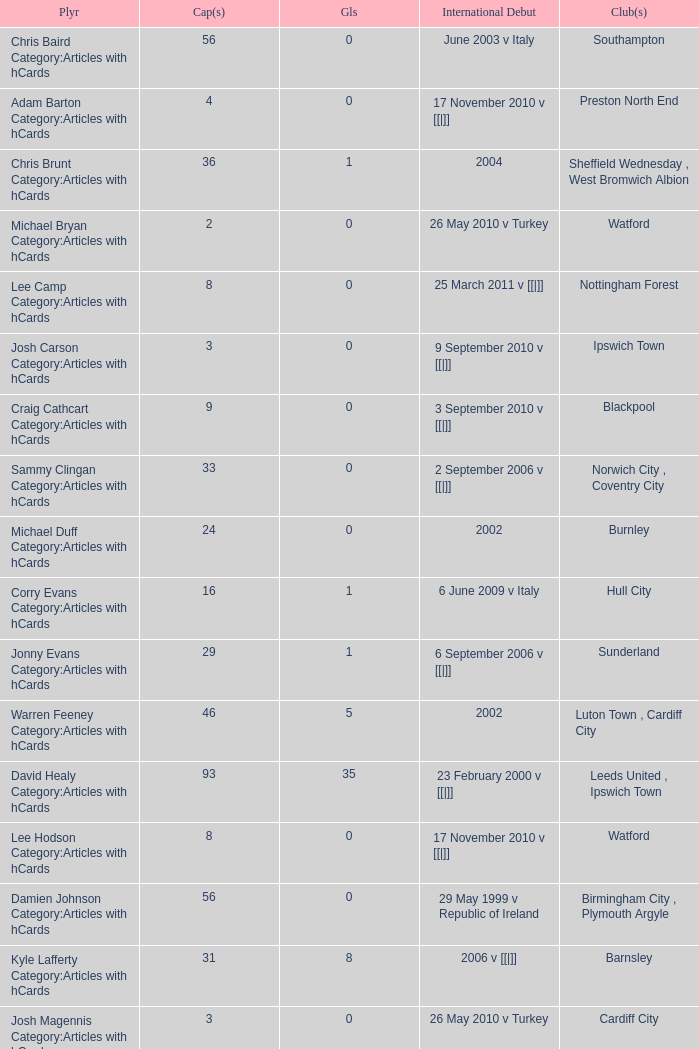How many caps figures are there for Norwich City, Coventry City? 1.0. 